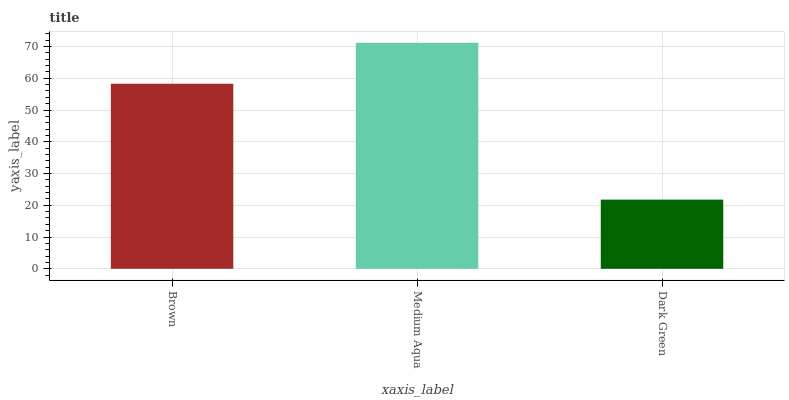Is Dark Green the minimum?
Answer yes or no. Yes. Is Medium Aqua the maximum?
Answer yes or no. Yes. Is Medium Aqua the minimum?
Answer yes or no. No. Is Dark Green the maximum?
Answer yes or no. No. Is Medium Aqua greater than Dark Green?
Answer yes or no. Yes. Is Dark Green less than Medium Aqua?
Answer yes or no. Yes. Is Dark Green greater than Medium Aqua?
Answer yes or no. No. Is Medium Aqua less than Dark Green?
Answer yes or no. No. Is Brown the high median?
Answer yes or no. Yes. Is Brown the low median?
Answer yes or no. Yes. Is Medium Aqua the high median?
Answer yes or no. No. Is Medium Aqua the low median?
Answer yes or no. No. 